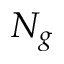Convert formula to latex. <formula><loc_0><loc_0><loc_500><loc_500>N _ { g }</formula> 